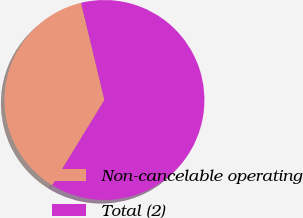<chart> <loc_0><loc_0><loc_500><loc_500><pie_chart><fcel>Non-cancelable operating<fcel>Total (2)<nl><fcel>37.5%<fcel>62.5%<nl></chart> 